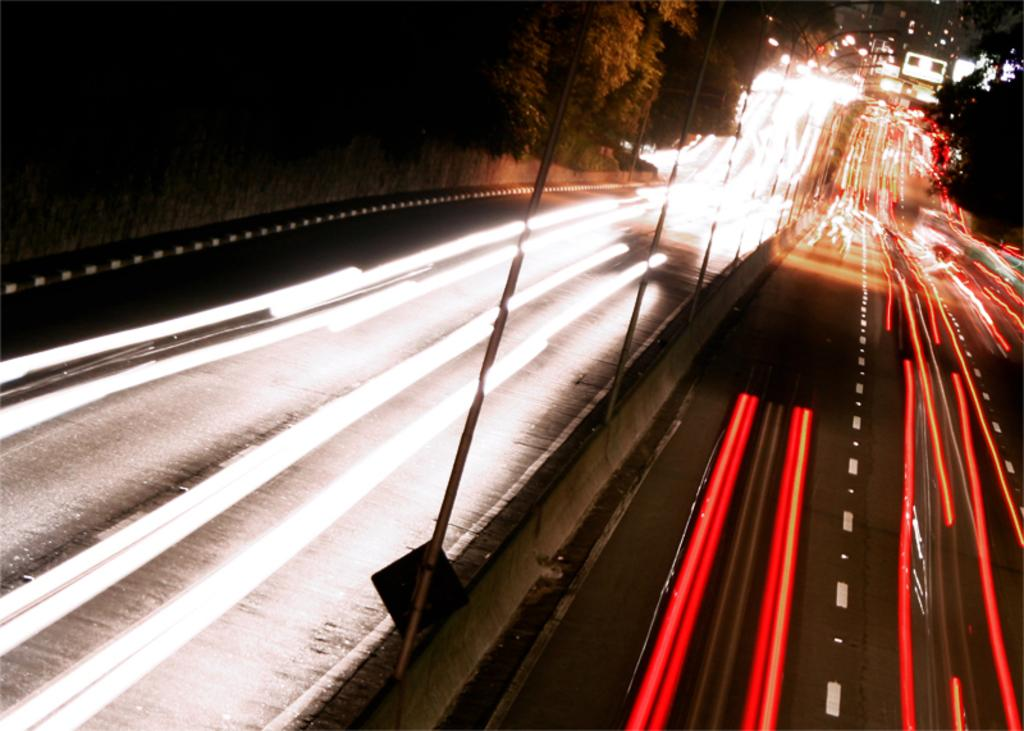What is the main feature of the image? There is a road in the image. What else can be seen along the road? There are poles and trees visible in the image. Are there any vehicles present in the image? Yes, there are vehicles in the image. What type of writing can be seen on the trees in the image? There is no writing visible on the trees in the image. How many beds are present in the image? There are no beds present in the image. 